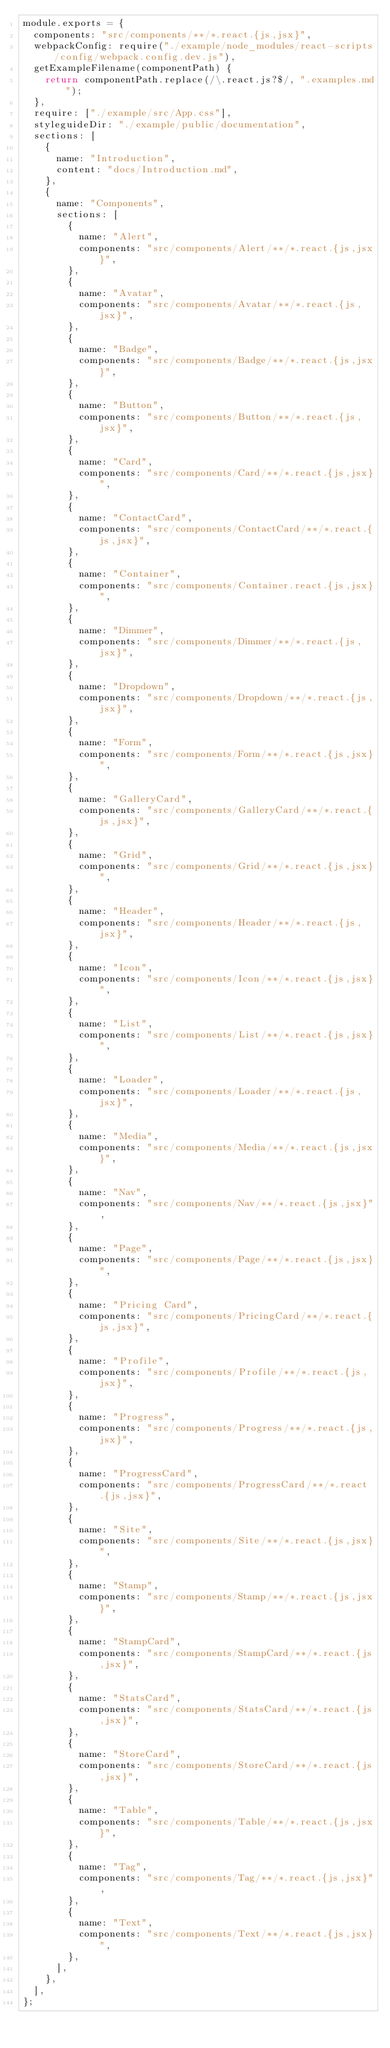<code> <loc_0><loc_0><loc_500><loc_500><_JavaScript_>module.exports = {
  components: "src/components/**/*.react.{js,jsx}",
  webpackConfig: require("./example/node_modules/react-scripts/config/webpack.config.dev.js"),
  getExampleFilename(componentPath) {
    return componentPath.replace(/\.react.js?$/, ".examples.md");
  },
  require: ["./example/src/App.css"],
  styleguideDir: "./example/public/documentation",
  sections: [
    {
      name: "Introduction",
      content: "docs/Introduction.md",
    },
    {
      name: "Components",
      sections: [
        {
          name: "Alert",
          components: "src/components/Alert/**/*.react.{js,jsx}",
        },
        {
          name: "Avatar",
          components: "src/components/Avatar/**/*.react.{js,jsx}",
        },
        {
          name: "Badge",
          components: "src/components/Badge/**/*.react.{js,jsx}",
        },
        {
          name: "Button",
          components: "src/components/Button/**/*.react.{js,jsx}",
        },
        {
          name: "Card",
          components: "src/components/Card/**/*.react.{js,jsx}",
        },
        {
          name: "ContactCard",
          components: "src/components/ContactCard/**/*.react.{js,jsx}",
        },
        {
          name: "Container",
          components: "src/components/Container.react.{js,jsx}",
        },
        {
          name: "Dimmer",
          components: "src/components/Dimmer/**/*.react.{js,jsx}",
        },
        {
          name: "Dropdown",
          components: "src/components/Dropdown/**/*.react.{js,jsx}",
        },
        {
          name: "Form",
          components: "src/components/Form/**/*.react.{js,jsx}",
        },
        {
          name: "GalleryCard",
          components: "src/components/GalleryCard/**/*.react.{js,jsx}",
        },
        {
          name: "Grid",
          components: "src/components/Grid/**/*.react.{js,jsx}",
        },
        {
          name: "Header",
          components: "src/components/Header/**/*.react.{js,jsx}",
        },
        {
          name: "Icon",
          components: "src/components/Icon/**/*.react.{js,jsx}",
        },
        {
          name: "List",
          components: "src/components/List/**/*.react.{js,jsx}",
        },
        {
          name: "Loader",
          components: "src/components/Loader/**/*.react.{js,jsx}",
        },
        {
          name: "Media",
          components: "src/components/Media/**/*.react.{js,jsx}",
        },
        {
          name: "Nav",
          components: "src/components/Nav/**/*.react.{js,jsx}",
        },
        {
          name: "Page",
          components: "src/components/Page/**/*.react.{js,jsx}",
        },
        {
          name: "Pricing Card",
          components: "src/components/PricingCard/**/*.react.{js,jsx}",
        },
        {
          name: "Profile",
          components: "src/components/Profile/**/*.react.{js,jsx}",
        },
        {
          name: "Progress",
          components: "src/components/Progress/**/*.react.{js,jsx}",
        },
        {
          name: "ProgressCard",
          components: "src/components/ProgressCard/**/*.react.{js,jsx}",
        },
        {
          name: "Site",
          components: "src/components/Site/**/*.react.{js,jsx}",
        },
        {
          name: "Stamp",
          components: "src/components/Stamp/**/*.react.{js,jsx}",
        },
        {
          name: "StampCard",
          components: "src/components/StampCard/**/*.react.{js,jsx}",
        },
        {
          name: "StatsCard",
          components: "src/components/StatsCard/**/*.react.{js,jsx}",
        },
        {
          name: "StoreCard",
          components: "src/components/StoreCard/**/*.react.{js,jsx}",
        },
        {
          name: "Table",
          components: "src/components/Table/**/*.react.{js,jsx}",
        },
        {
          name: "Tag",
          components: "src/components/Tag/**/*.react.{js,jsx}",
        },
        {
          name: "Text",
          components: "src/components/Text/**/*.react.{js,jsx}",
        },
      ],
    },
  ],
};
</code> 